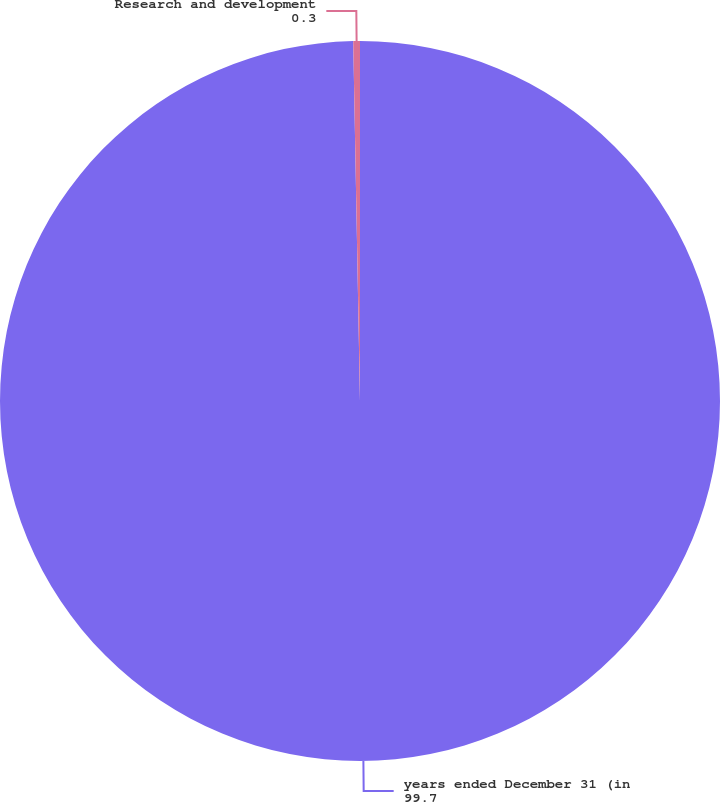Convert chart to OTSL. <chart><loc_0><loc_0><loc_500><loc_500><pie_chart><fcel>years ended December 31 (in<fcel>Research and development<nl><fcel>99.7%<fcel>0.3%<nl></chart> 